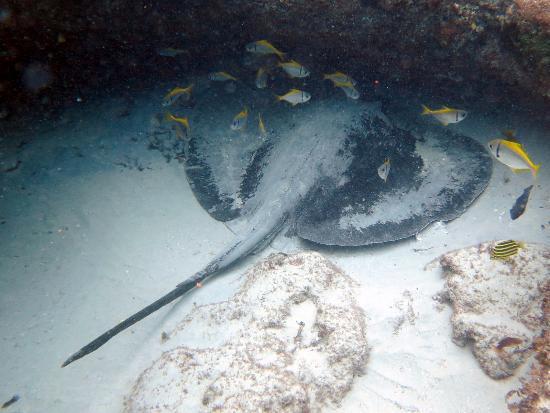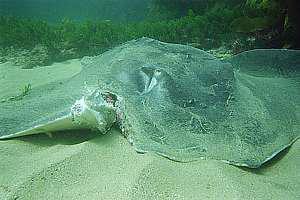The first image is the image on the left, the second image is the image on the right. Given the left and right images, does the statement "There are more rays in the image on the left than in the image on the right." hold true? Answer yes or no. No. The first image is the image on the left, the second image is the image on the right. For the images displayed, is the sentence "Both images include a stingray at the bottom of the ocean." factually correct? Answer yes or no. Yes. 